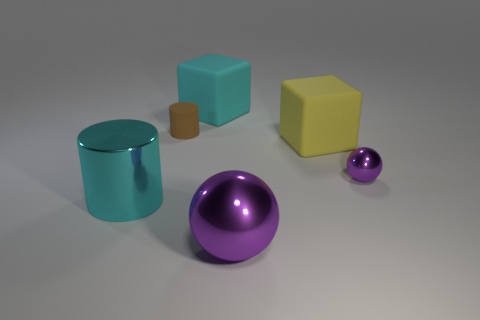Is there any indication about the material of these objects? While there are no explicit indications of material, the objects in the image have a plasticky sheen to them. The light reflects smoothly off their surfaces, suggesting that they could be made of a type of plastic or metal with a polished finish. The lack of texture and the uniform coloration further imply that these are not meant to represent any specific material but rather to focus on shape and color contrast. 